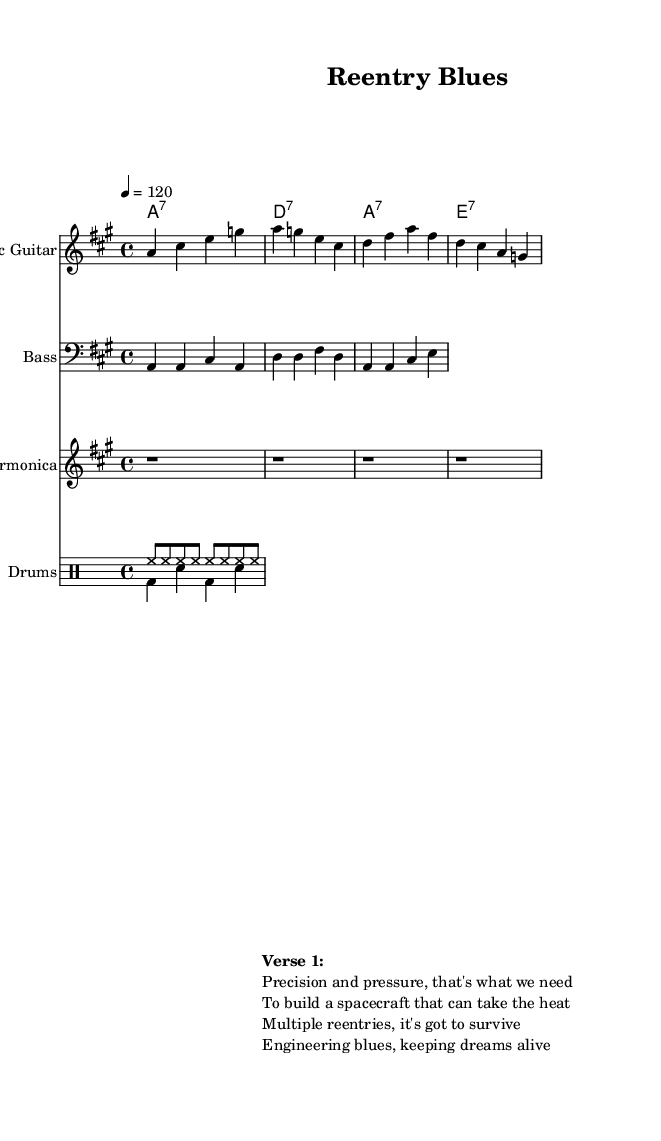What is the key signature of this music? The key signature is A major, which has three sharps (F#, C#, and G#). This is indicated at the beginning of the staff where the sharps are shown.
Answer: A major What is the time signature of this music? The time signature is 4/4, which is indicated in the beginning of the score. This means there are four beats in each measure, and a quarter note gets one beat.
Answer: 4/4 What is the tempo marking for this piece? The tempo marking is "4 = 120," which indicates that there are 120 beats per minute using the quarter note as the beat.
Answer: 120 How many measures are in the electric guitar part? In the electric guitar part, there are four measures, which can be counted in the notation provided.
Answer: 4 What is the first chord played in the chord progression? The first chord in the chord progression is A7, which is indicated by the notation at the beginning of the chord names.
Answer: A7 What kind of music is this piece classified as? This piece is classified as blues, more specifically Chicago-style electric blues, indicated by the overall style and instrumentation present in the score.
Answer: Blues What is the significance of the harmonica in this piece? The harmonica in this piece plays rest for all measures, indicating its role as an accompaniment or a placeholder for improvisation or silence rather than filling the score with notes.
Answer: Accompaniment 